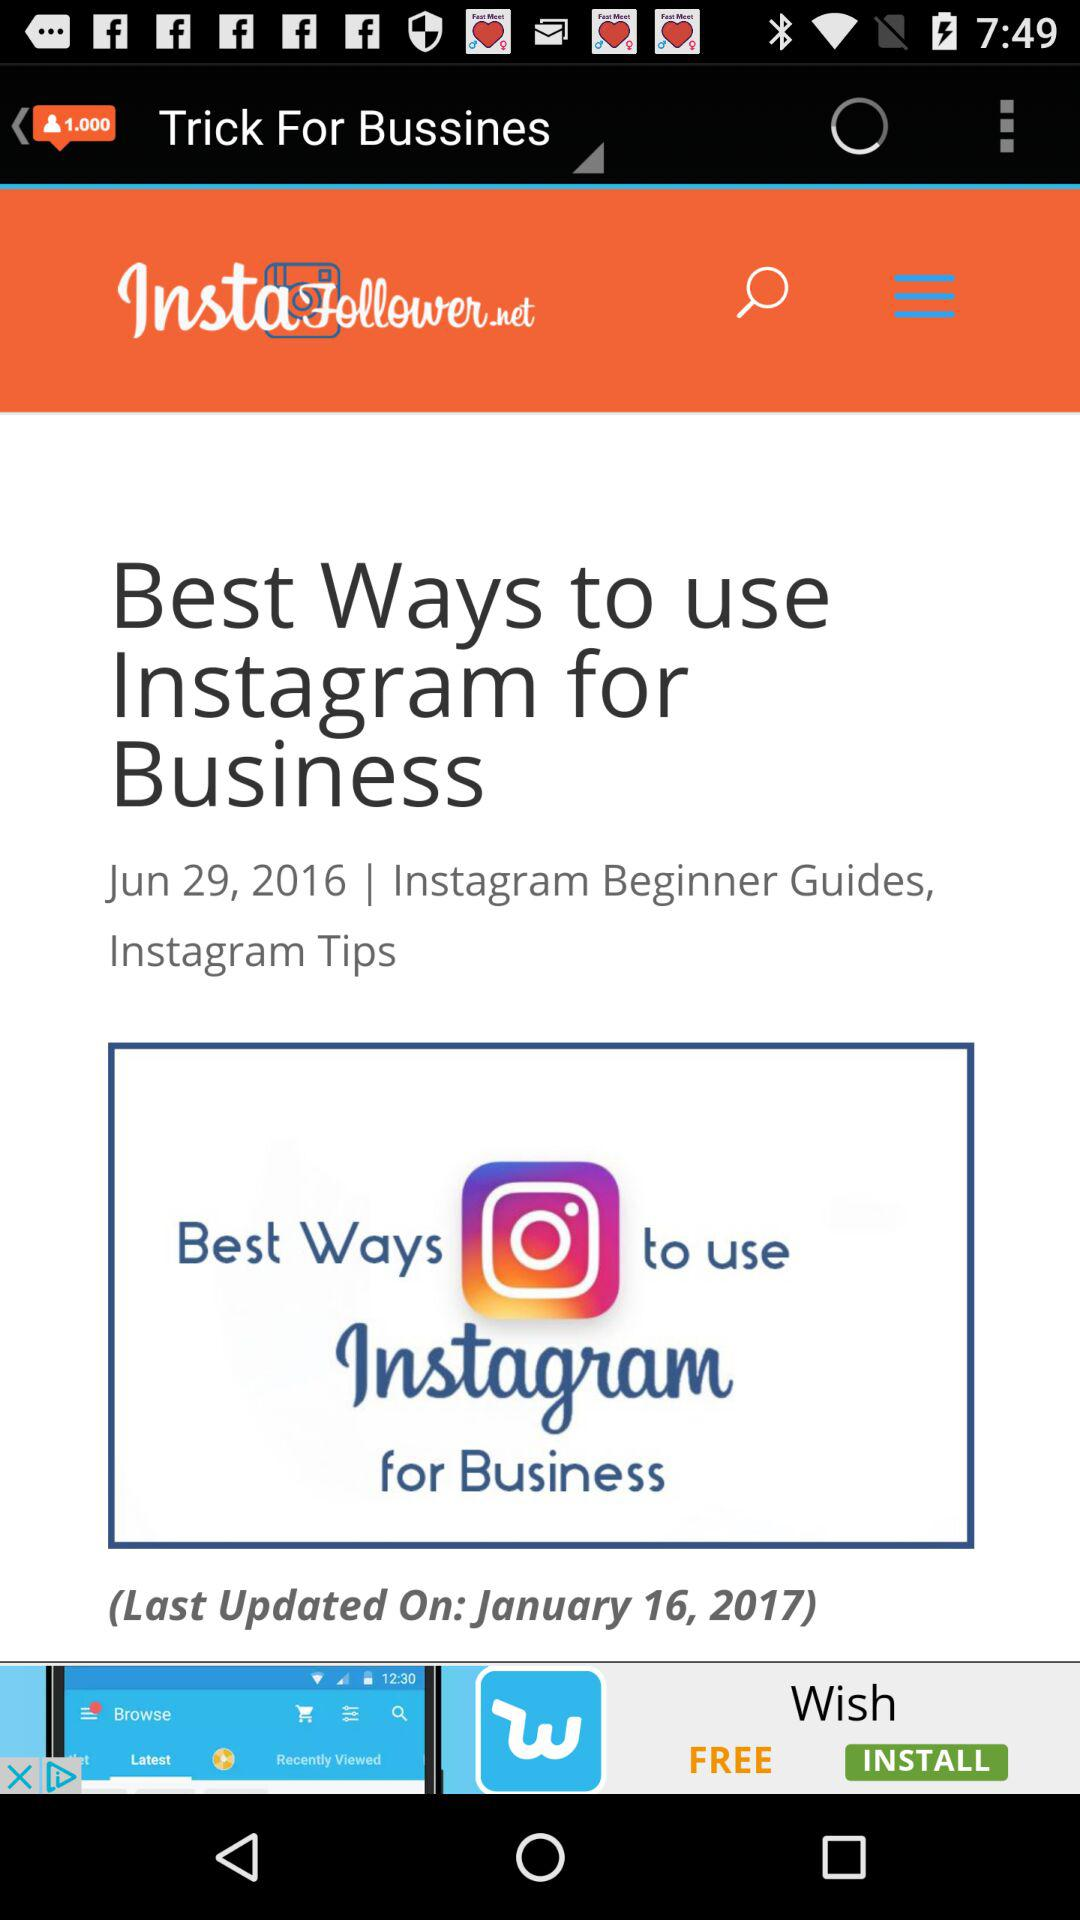On which date was the post "Best Ways to use Instagram for Business" uploaded? The post "Best Ways to use Instagram for Business" was uploaded on June 29, 2016. 